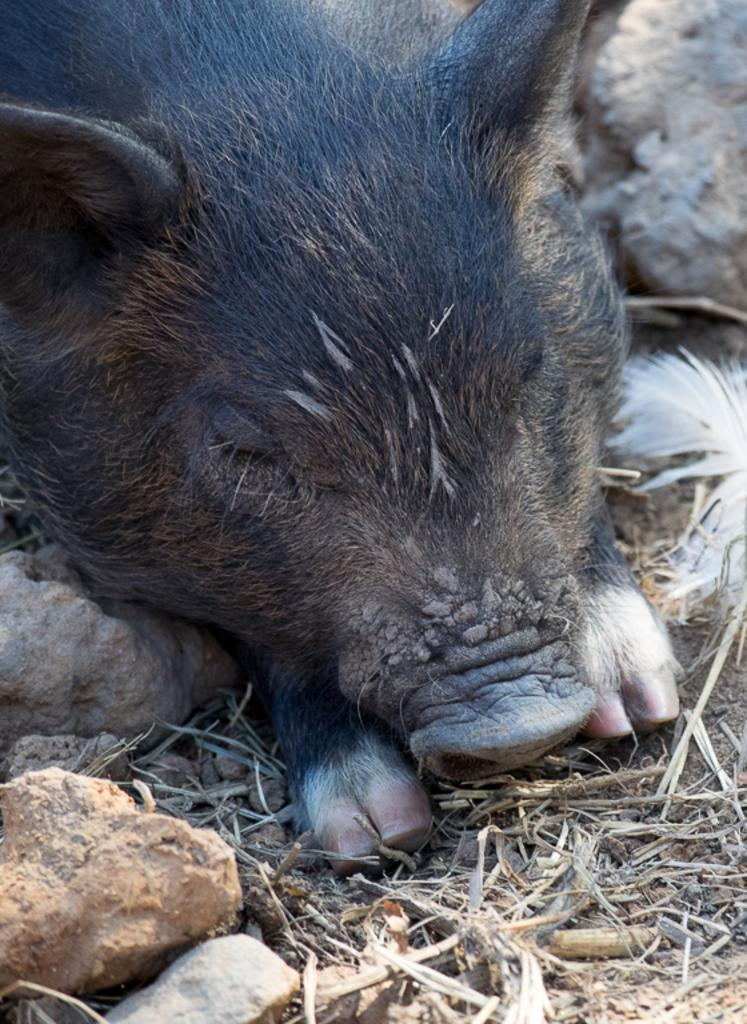What animal is present in the image? There is a pig in the image. What color is the pig? The pig is black in color. Can you see any ghosts interacting with the pig in the image? There are no ghosts present in the image; it only features a black pig. 